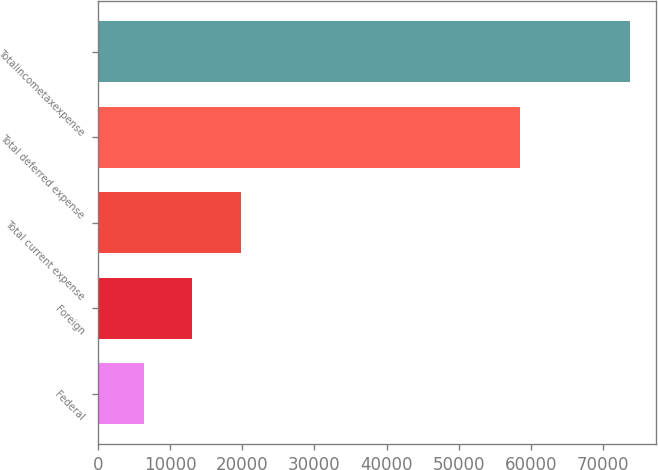Convert chart to OTSL. <chart><loc_0><loc_0><loc_500><loc_500><bar_chart><fcel>Federal<fcel>Foreign<fcel>Total current expense<fcel>Total deferred expense<fcel>Totalincometaxexpense<nl><fcel>6335<fcel>13072<fcel>19809<fcel>58556<fcel>73705<nl></chart> 